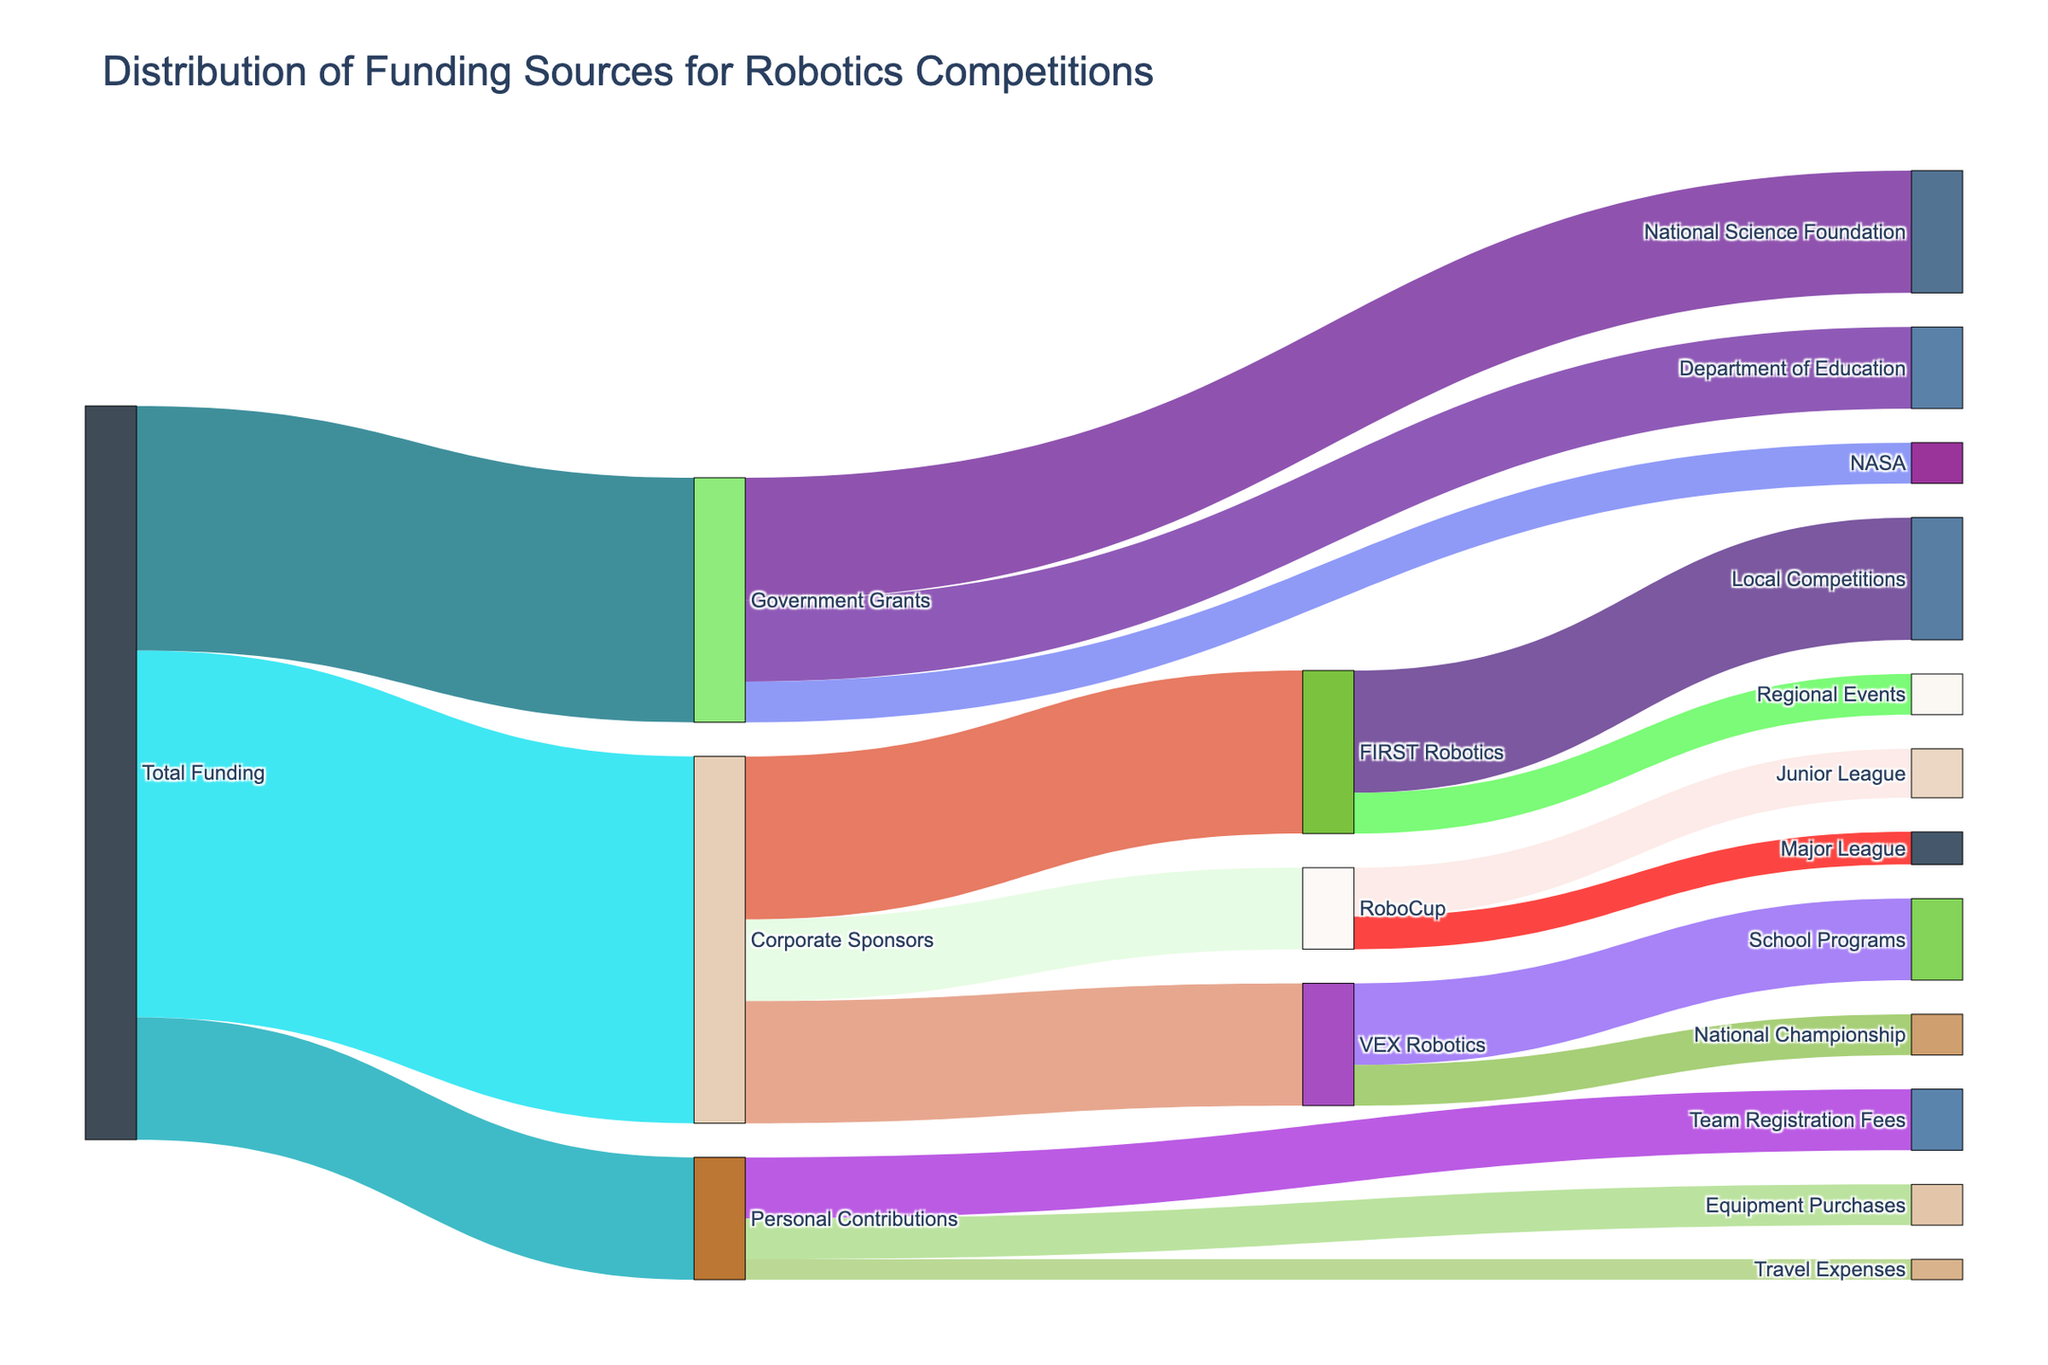what is the total funding amount? The total funding amount can be derived by summing up the contributions from Corporate Sponsors, Government Grants, and Personal Contributions, which are 450,000, 300,000, and 150,000 respectively.
Answer: 900,000 what are the main funding sources? The main funding sources are visible at the beginning of the branches: Corporate Sponsors, Government Grants, and Personal Contributions.
Answer: Corporate Sponsors, Government Grants, Personal Contributions which category received the highest funding from corporate sponsors? First, identify the links branching from Corporate Sponsors. Compare the amounts going to FIRST Robotics, VEX Robotics, and RoboCup. FIRST Robotics received 200,000, which is the highest.
Answer: FIRST Robotics how much total funding did FIRST Robotics receive? Sum the inputs to FIRST Robotics: 200,000 from Corporate Sponsors and add further breakdowns if necessary. Here, it's directly 200,000.
Answer: 200,000 compare the funding between National Science Foundation and Department of Education. Identify the funding amounts under Government Grants. National Science Foundation received 150,000 and Department of Education received 100,000.
Answer: National Science Foundation received more what is the smallest personal contribution category? Look at the amounts under Personal Contributions. Compare Team Registration Fees (75,000), Equipment Purchases (50,000), and Travel Expenses (25,000). Travel Expenses is the smallest.
Answer: Travel Expenses how much did VEX Robotics receive for School Programs? VEX Robotics received 150,000 from Corporate Sponsors. Of this, 100,000 is allocated to School Programs as indicated in the breakdown.
Answer: 100,000 what proportion of total funding comes from government grants? Government Grants amount is 300,000. Divide 300,000 by the total funding amount, 900,000, to get the proportion: 300,000/900,000 = 1/3 or approximately 33.3%.
Answer: 33.3% did RoboCup receive more funding for Junior League or Major League? From Corporate Sponsors, RoboCup received a total of 100,000. It distributed 60,000 to Junior League and 40,000 to Major League.
Answer: Junior League 